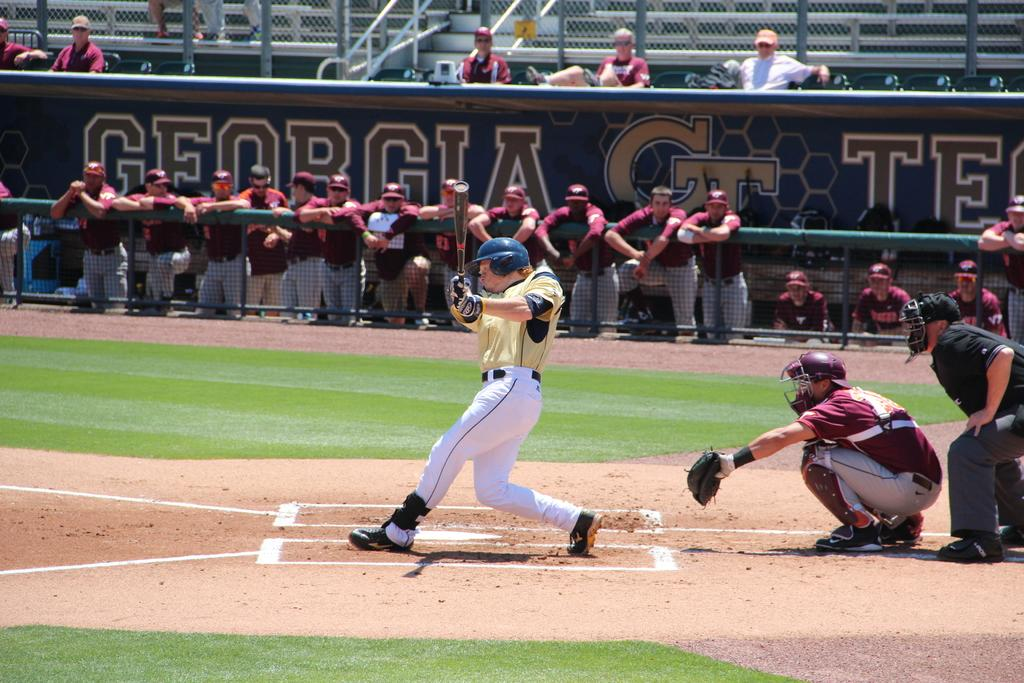<image>
Give a short and clear explanation of the subsequent image. The Georgia team watches the opponent swing at the pitch. 